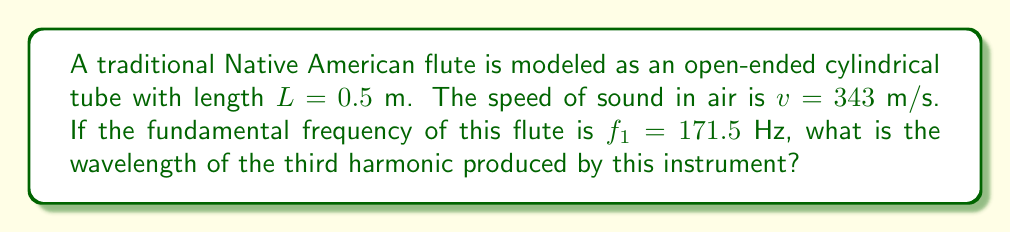Could you help me with this problem? To solve this problem, we'll follow these steps:

1) For an open-ended cylindrical tube, the fundamental frequency $f_1$ is given by:

   $$f_1 = \frac{v}{2L}$$

   where $v$ is the speed of sound and $L$ is the length of the tube.

2) We can verify this using the given values:

   $$f_1 = \frac{343}{2(0.5)} = 171.5\text{ Hz}$$

3) The frequencies of the harmonics in an open-ended tube are integer multiples of the fundamental frequency. The third harmonic corresponds to $n=3$:

   $$f_3 = 3f_1 = 3(171.5) = 514.5\text{ Hz}$$

4) To find the wavelength, we use the wave equation:

   $$v = f\lambda$$

   where $v$ is the speed of sound, $f$ is the frequency, and $\lambda$ is the wavelength.

5) Rearranging for $\lambda$ and substituting our values:

   $$\lambda = \frac{v}{f_3} = \frac{343}{514.5} \approx 0.6667\text{ m}$$

Thus, the wavelength of the third harmonic is approximately 0.6667 meters.
Answer: $0.6667\text{ m}$ 